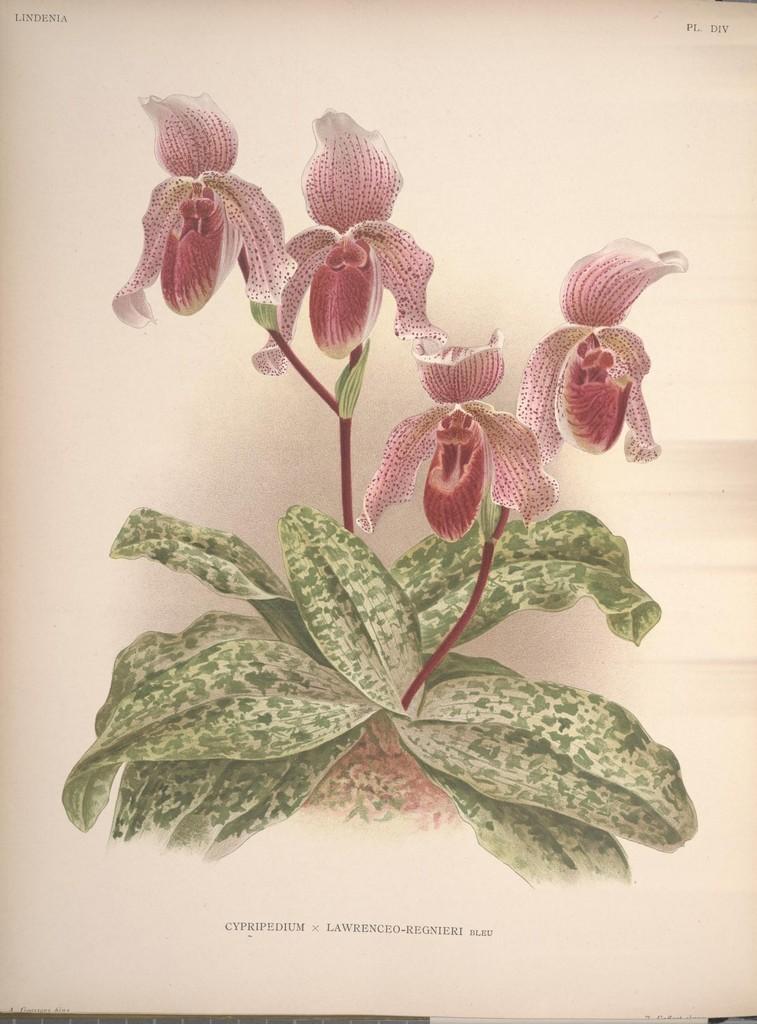Please provide a concise description of this image. In the image in the center, we can see one paper. On the paper, we can see plants and flowers. And we can see something written on the paper. 